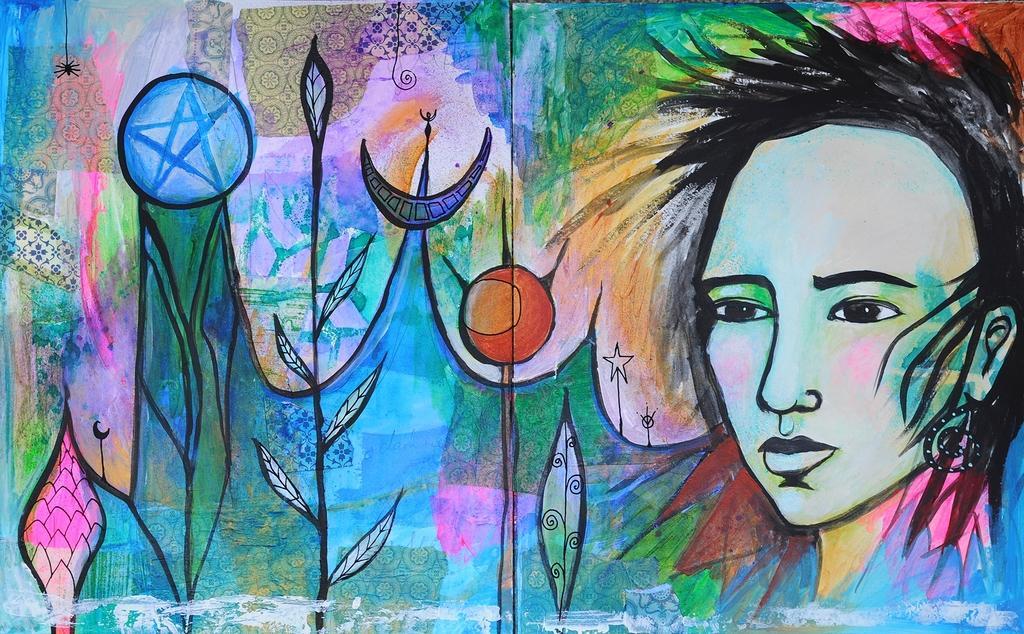Please provide a concise description of this image. The picture consists of a wall, on the wall there is painting. In the painting there are plants, a woman's face and other designs. 